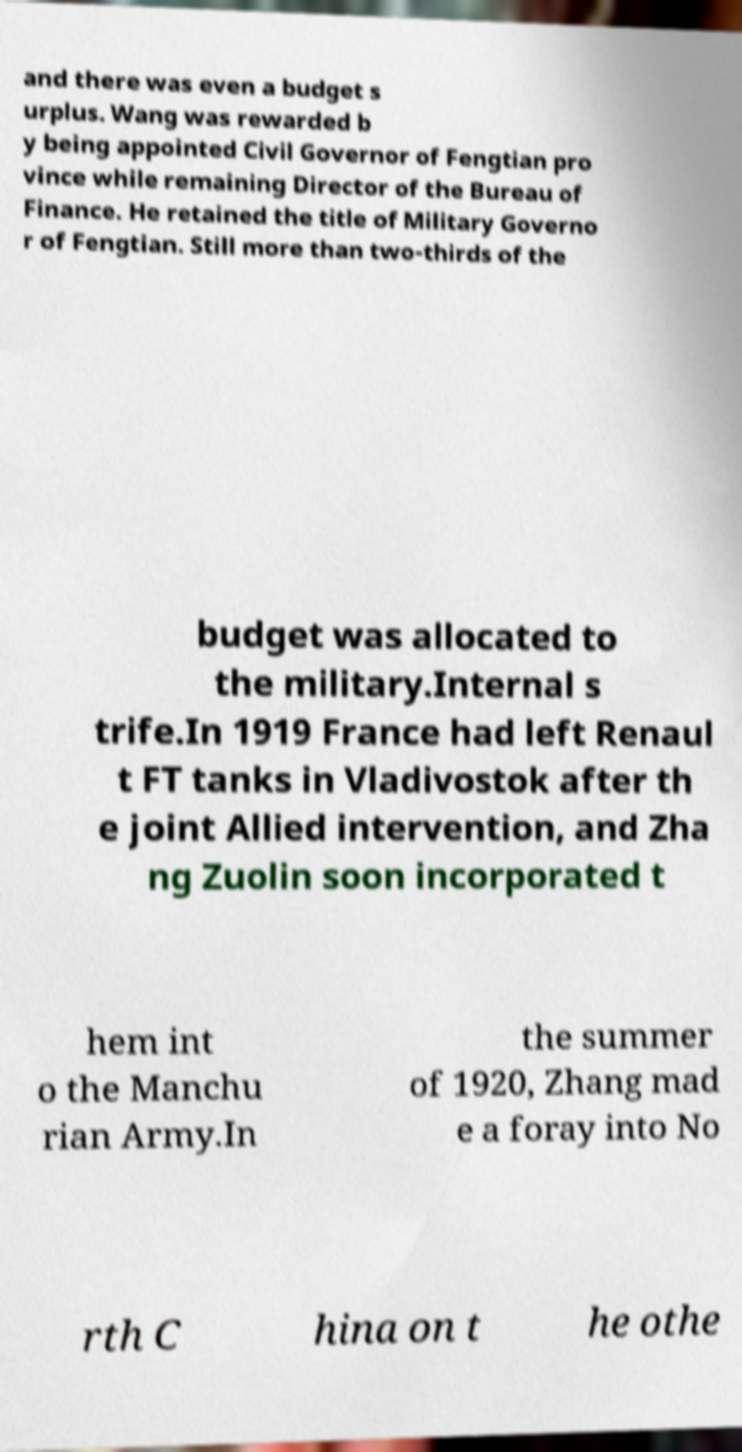Could you assist in decoding the text presented in this image and type it out clearly? and there was even a budget s urplus. Wang was rewarded b y being appointed Civil Governor of Fengtian pro vince while remaining Director of the Bureau of Finance. He retained the title of Military Governo r of Fengtian. Still more than two-thirds of the budget was allocated to the military.Internal s trife.In 1919 France had left Renaul t FT tanks in Vladivostok after th e joint Allied intervention, and Zha ng Zuolin soon incorporated t hem int o the Manchu rian Army.In the summer of 1920, Zhang mad e a foray into No rth C hina on t he othe 